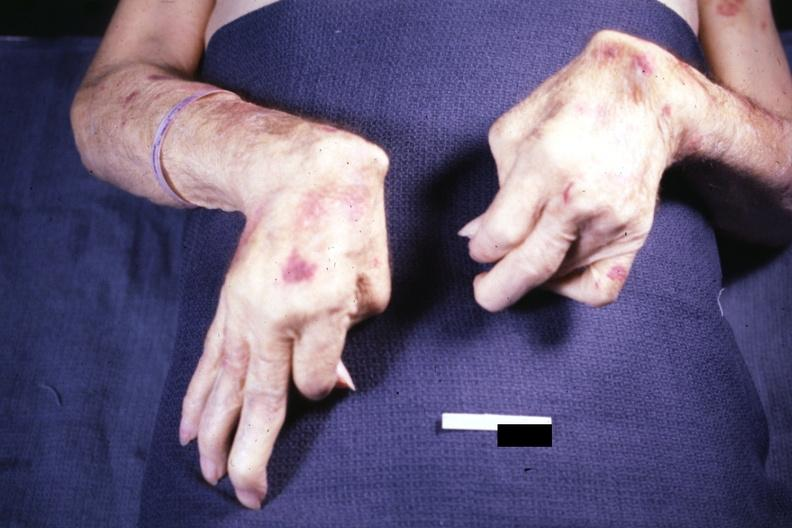what are present?
Answer the question using a single word or phrase. Extremities 